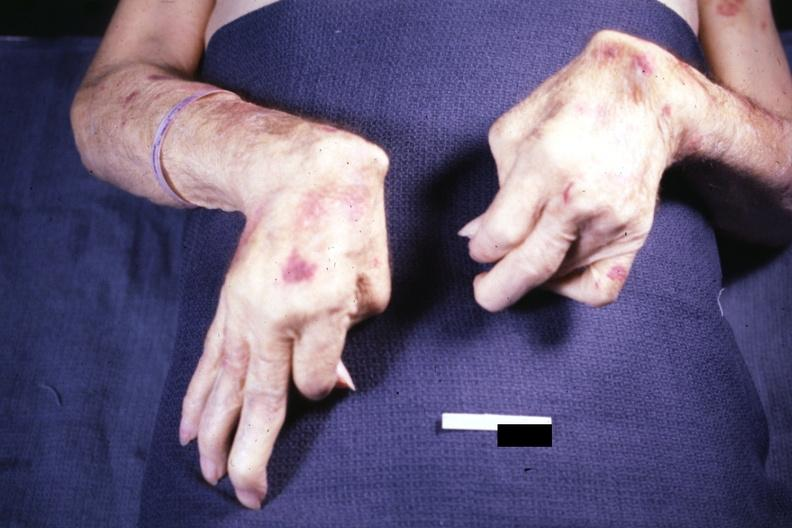what are present?
Answer the question using a single word or phrase. Extremities 